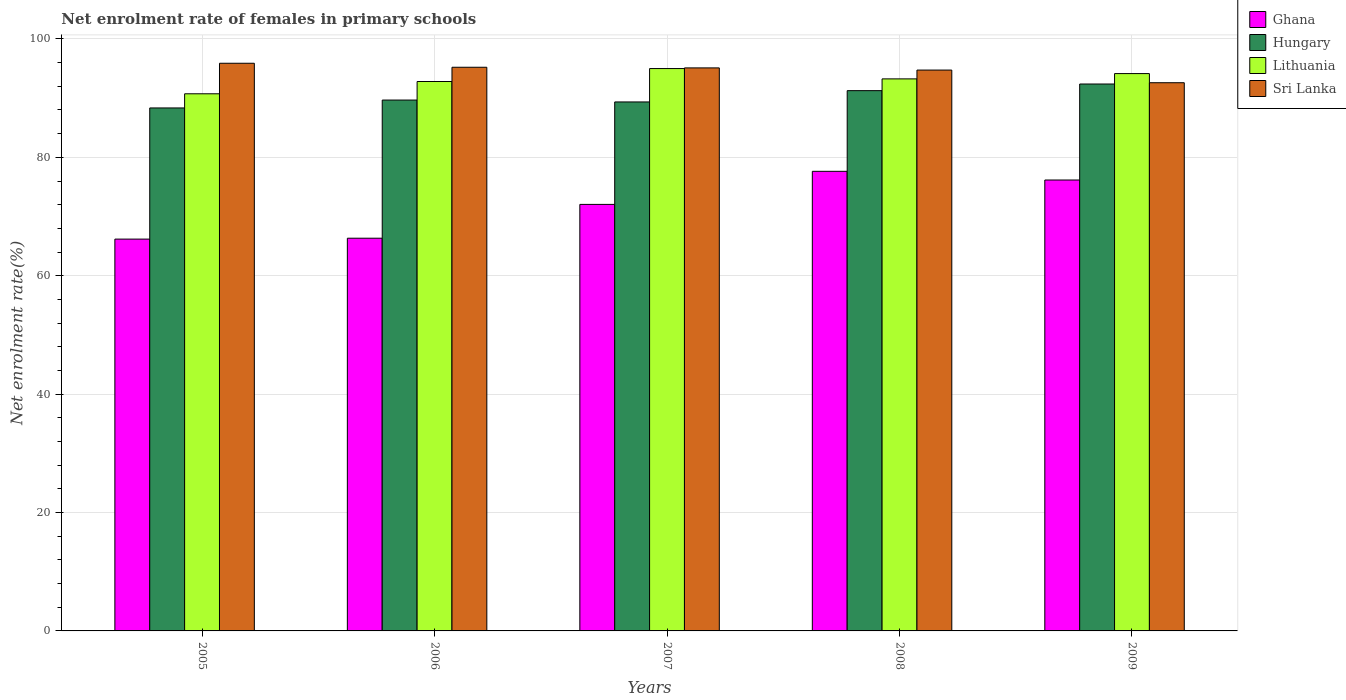Are the number of bars on each tick of the X-axis equal?
Offer a very short reply. Yes. How many bars are there on the 1st tick from the left?
Keep it short and to the point. 4. How many bars are there on the 4th tick from the right?
Keep it short and to the point. 4. What is the label of the 2nd group of bars from the left?
Your response must be concise. 2006. In how many cases, is the number of bars for a given year not equal to the number of legend labels?
Your answer should be compact. 0. What is the net enrolment rate of females in primary schools in Sri Lanka in 2008?
Offer a very short reply. 94.74. Across all years, what is the maximum net enrolment rate of females in primary schools in Lithuania?
Offer a very short reply. 95. Across all years, what is the minimum net enrolment rate of females in primary schools in Hungary?
Give a very brief answer. 88.35. In which year was the net enrolment rate of females in primary schools in Sri Lanka maximum?
Your answer should be very brief. 2005. In which year was the net enrolment rate of females in primary schools in Sri Lanka minimum?
Give a very brief answer. 2009. What is the total net enrolment rate of females in primary schools in Lithuania in the graph?
Ensure brevity in your answer.  465.96. What is the difference between the net enrolment rate of females in primary schools in Hungary in 2006 and that in 2007?
Ensure brevity in your answer.  0.32. What is the difference between the net enrolment rate of females in primary schools in Hungary in 2007 and the net enrolment rate of females in primary schools in Lithuania in 2005?
Your response must be concise. -1.38. What is the average net enrolment rate of females in primary schools in Lithuania per year?
Your response must be concise. 93.19. In the year 2009, what is the difference between the net enrolment rate of females in primary schools in Ghana and net enrolment rate of females in primary schools in Hungary?
Ensure brevity in your answer.  -16.22. In how many years, is the net enrolment rate of females in primary schools in Sri Lanka greater than 12 %?
Offer a very short reply. 5. What is the ratio of the net enrolment rate of females in primary schools in Ghana in 2006 to that in 2007?
Give a very brief answer. 0.92. Is the net enrolment rate of females in primary schools in Sri Lanka in 2008 less than that in 2009?
Provide a short and direct response. No. Is the difference between the net enrolment rate of females in primary schools in Ghana in 2005 and 2009 greater than the difference between the net enrolment rate of females in primary schools in Hungary in 2005 and 2009?
Your response must be concise. No. What is the difference between the highest and the second highest net enrolment rate of females in primary schools in Lithuania?
Provide a succinct answer. 0.85. What is the difference between the highest and the lowest net enrolment rate of females in primary schools in Ghana?
Provide a succinct answer. 11.45. In how many years, is the net enrolment rate of females in primary schools in Lithuania greater than the average net enrolment rate of females in primary schools in Lithuania taken over all years?
Your response must be concise. 3. Is the sum of the net enrolment rate of females in primary schools in Sri Lanka in 2005 and 2009 greater than the maximum net enrolment rate of females in primary schools in Ghana across all years?
Your answer should be compact. Yes. What does the 4th bar from the left in 2005 represents?
Your answer should be compact. Sri Lanka. What does the 4th bar from the right in 2008 represents?
Keep it short and to the point. Ghana. Are all the bars in the graph horizontal?
Give a very brief answer. No. How many legend labels are there?
Offer a very short reply. 4. What is the title of the graph?
Offer a very short reply. Net enrolment rate of females in primary schools. What is the label or title of the X-axis?
Offer a very short reply. Years. What is the label or title of the Y-axis?
Your answer should be compact. Net enrolment rate(%). What is the Net enrolment rate(%) of Ghana in 2005?
Offer a terse response. 66.19. What is the Net enrolment rate(%) of Hungary in 2005?
Provide a succinct answer. 88.35. What is the Net enrolment rate(%) in Lithuania in 2005?
Provide a short and direct response. 90.74. What is the Net enrolment rate(%) of Sri Lanka in 2005?
Provide a short and direct response. 95.89. What is the Net enrolment rate(%) in Ghana in 2006?
Make the answer very short. 66.34. What is the Net enrolment rate(%) of Hungary in 2006?
Keep it short and to the point. 89.68. What is the Net enrolment rate(%) in Lithuania in 2006?
Give a very brief answer. 92.81. What is the Net enrolment rate(%) in Sri Lanka in 2006?
Your answer should be very brief. 95.22. What is the Net enrolment rate(%) of Ghana in 2007?
Provide a succinct answer. 72.05. What is the Net enrolment rate(%) in Hungary in 2007?
Make the answer very short. 89.36. What is the Net enrolment rate(%) in Lithuania in 2007?
Provide a short and direct response. 95. What is the Net enrolment rate(%) in Sri Lanka in 2007?
Ensure brevity in your answer.  95.11. What is the Net enrolment rate(%) of Ghana in 2008?
Provide a succinct answer. 77.64. What is the Net enrolment rate(%) in Hungary in 2008?
Your response must be concise. 91.27. What is the Net enrolment rate(%) of Lithuania in 2008?
Your answer should be compact. 93.25. What is the Net enrolment rate(%) in Sri Lanka in 2008?
Provide a succinct answer. 94.74. What is the Net enrolment rate(%) of Ghana in 2009?
Make the answer very short. 76.17. What is the Net enrolment rate(%) of Hungary in 2009?
Give a very brief answer. 92.39. What is the Net enrolment rate(%) of Lithuania in 2009?
Offer a very short reply. 94.15. What is the Net enrolment rate(%) of Sri Lanka in 2009?
Ensure brevity in your answer.  92.61. Across all years, what is the maximum Net enrolment rate(%) of Ghana?
Offer a terse response. 77.64. Across all years, what is the maximum Net enrolment rate(%) in Hungary?
Provide a short and direct response. 92.39. Across all years, what is the maximum Net enrolment rate(%) of Lithuania?
Make the answer very short. 95. Across all years, what is the maximum Net enrolment rate(%) in Sri Lanka?
Your answer should be compact. 95.89. Across all years, what is the minimum Net enrolment rate(%) of Ghana?
Ensure brevity in your answer.  66.19. Across all years, what is the minimum Net enrolment rate(%) in Hungary?
Give a very brief answer. 88.35. Across all years, what is the minimum Net enrolment rate(%) in Lithuania?
Your answer should be compact. 90.74. Across all years, what is the minimum Net enrolment rate(%) of Sri Lanka?
Make the answer very short. 92.61. What is the total Net enrolment rate(%) in Ghana in the graph?
Your answer should be compact. 358.4. What is the total Net enrolment rate(%) in Hungary in the graph?
Give a very brief answer. 451.04. What is the total Net enrolment rate(%) of Lithuania in the graph?
Your answer should be very brief. 465.96. What is the total Net enrolment rate(%) in Sri Lanka in the graph?
Provide a short and direct response. 473.58. What is the difference between the Net enrolment rate(%) in Ghana in 2005 and that in 2006?
Offer a terse response. -0.15. What is the difference between the Net enrolment rate(%) of Hungary in 2005 and that in 2006?
Offer a very short reply. -1.33. What is the difference between the Net enrolment rate(%) in Lithuania in 2005 and that in 2006?
Offer a very short reply. -2.07. What is the difference between the Net enrolment rate(%) of Sri Lanka in 2005 and that in 2006?
Your answer should be compact. 0.68. What is the difference between the Net enrolment rate(%) of Ghana in 2005 and that in 2007?
Your answer should be compact. -5.86. What is the difference between the Net enrolment rate(%) in Hungary in 2005 and that in 2007?
Offer a very short reply. -1.01. What is the difference between the Net enrolment rate(%) in Lithuania in 2005 and that in 2007?
Your answer should be compact. -4.26. What is the difference between the Net enrolment rate(%) in Sri Lanka in 2005 and that in 2007?
Provide a succinct answer. 0.78. What is the difference between the Net enrolment rate(%) in Ghana in 2005 and that in 2008?
Provide a short and direct response. -11.45. What is the difference between the Net enrolment rate(%) in Hungary in 2005 and that in 2008?
Provide a short and direct response. -2.92. What is the difference between the Net enrolment rate(%) of Lithuania in 2005 and that in 2008?
Give a very brief answer. -2.52. What is the difference between the Net enrolment rate(%) of Sri Lanka in 2005 and that in 2008?
Your answer should be very brief. 1.15. What is the difference between the Net enrolment rate(%) of Ghana in 2005 and that in 2009?
Provide a short and direct response. -9.98. What is the difference between the Net enrolment rate(%) in Hungary in 2005 and that in 2009?
Provide a short and direct response. -4.04. What is the difference between the Net enrolment rate(%) of Lithuania in 2005 and that in 2009?
Your answer should be very brief. -3.41. What is the difference between the Net enrolment rate(%) in Sri Lanka in 2005 and that in 2009?
Give a very brief answer. 3.29. What is the difference between the Net enrolment rate(%) in Ghana in 2006 and that in 2007?
Make the answer very short. -5.71. What is the difference between the Net enrolment rate(%) in Hungary in 2006 and that in 2007?
Keep it short and to the point. 0.32. What is the difference between the Net enrolment rate(%) of Lithuania in 2006 and that in 2007?
Your answer should be very brief. -2.19. What is the difference between the Net enrolment rate(%) of Sri Lanka in 2006 and that in 2007?
Provide a short and direct response. 0.11. What is the difference between the Net enrolment rate(%) of Ghana in 2006 and that in 2008?
Your response must be concise. -11.3. What is the difference between the Net enrolment rate(%) in Hungary in 2006 and that in 2008?
Ensure brevity in your answer.  -1.59. What is the difference between the Net enrolment rate(%) of Lithuania in 2006 and that in 2008?
Make the answer very short. -0.44. What is the difference between the Net enrolment rate(%) of Sri Lanka in 2006 and that in 2008?
Make the answer very short. 0.47. What is the difference between the Net enrolment rate(%) in Ghana in 2006 and that in 2009?
Give a very brief answer. -9.83. What is the difference between the Net enrolment rate(%) in Hungary in 2006 and that in 2009?
Offer a very short reply. -2.71. What is the difference between the Net enrolment rate(%) in Lithuania in 2006 and that in 2009?
Provide a short and direct response. -1.34. What is the difference between the Net enrolment rate(%) in Sri Lanka in 2006 and that in 2009?
Your response must be concise. 2.61. What is the difference between the Net enrolment rate(%) of Ghana in 2007 and that in 2008?
Your answer should be compact. -5.59. What is the difference between the Net enrolment rate(%) of Hungary in 2007 and that in 2008?
Your answer should be very brief. -1.91. What is the difference between the Net enrolment rate(%) of Lithuania in 2007 and that in 2008?
Ensure brevity in your answer.  1.74. What is the difference between the Net enrolment rate(%) in Sri Lanka in 2007 and that in 2008?
Offer a very short reply. 0.37. What is the difference between the Net enrolment rate(%) of Ghana in 2007 and that in 2009?
Provide a short and direct response. -4.12. What is the difference between the Net enrolment rate(%) of Hungary in 2007 and that in 2009?
Offer a very short reply. -3.03. What is the difference between the Net enrolment rate(%) in Lithuania in 2007 and that in 2009?
Your answer should be compact. 0.85. What is the difference between the Net enrolment rate(%) of Sri Lanka in 2007 and that in 2009?
Your answer should be compact. 2.5. What is the difference between the Net enrolment rate(%) in Ghana in 2008 and that in 2009?
Your answer should be very brief. 1.47. What is the difference between the Net enrolment rate(%) in Hungary in 2008 and that in 2009?
Provide a short and direct response. -1.12. What is the difference between the Net enrolment rate(%) of Lithuania in 2008 and that in 2009?
Offer a very short reply. -0.9. What is the difference between the Net enrolment rate(%) in Sri Lanka in 2008 and that in 2009?
Give a very brief answer. 2.14. What is the difference between the Net enrolment rate(%) of Ghana in 2005 and the Net enrolment rate(%) of Hungary in 2006?
Keep it short and to the point. -23.49. What is the difference between the Net enrolment rate(%) in Ghana in 2005 and the Net enrolment rate(%) in Lithuania in 2006?
Your response must be concise. -26.62. What is the difference between the Net enrolment rate(%) in Ghana in 2005 and the Net enrolment rate(%) in Sri Lanka in 2006?
Ensure brevity in your answer.  -29.03. What is the difference between the Net enrolment rate(%) of Hungary in 2005 and the Net enrolment rate(%) of Lithuania in 2006?
Make the answer very short. -4.47. What is the difference between the Net enrolment rate(%) in Hungary in 2005 and the Net enrolment rate(%) in Sri Lanka in 2006?
Make the answer very short. -6.87. What is the difference between the Net enrolment rate(%) of Lithuania in 2005 and the Net enrolment rate(%) of Sri Lanka in 2006?
Your answer should be very brief. -4.48. What is the difference between the Net enrolment rate(%) in Ghana in 2005 and the Net enrolment rate(%) in Hungary in 2007?
Make the answer very short. -23.17. What is the difference between the Net enrolment rate(%) of Ghana in 2005 and the Net enrolment rate(%) of Lithuania in 2007?
Your answer should be compact. -28.81. What is the difference between the Net enrolment rate(%) of Ghana in 2005 and the Net enrolment rate(%) of Sri Lanka in 2007?
Provide a short and direct response. -28.92. What is the difference between the Net enrolment rate(%) of Hungary in 2005 and the Net enrolment rate(%) of Lithuania in 2007?
Give a very brief answer. -6.65. What is the difference between the Net enrolment rate(%) in Hungary in 2005 and the Net enrolment rate(%) in Sri Lanka in 2007?
Your answer should be very brief. -6.76. What is the difference between the Net enrolment rate(%) in Lithuania in 2005 and the Net enrolment rate(%) in Sri Lanka in 2007?
Offer a very short reply. -4.37. What is the difference between the Net enrolment rate(%) of Ghana in 2005 and the Net enrolment rate(%) of Hungary in 2008?
Offer a very short reply. -25.08. What is the difference between the Net enrolment rate(%) of Ghana in 2005 and the Net enrolment rate(%) of Lithuania in 2008?
Provide a succinct answer. -27.06. What is the difference between the Net enrolment rate(%) of Ghana in 2005 and the Net enrolment rate(%) of Sri Lanka in 2008?
Keep it short and to the point. -28.55. What is the difference between the Net enrolment rate(%) in Hungary in 2005 and the Net enrolment rate(%) in Lithuania in 2008?
Your response must be concise. -4.91. What is the difference between the Net enrolment rate(%) of Hungary in 2005 and the Net enrolment rate(%) of Sri Lanka in 2008?
Your answer should be compact. -6.4. What is the difference between the Net enrolment rate(%) in Lithuania in 2005 and the Net enrolment rate(%) in Sri Lanka in 2008?
Keep it short and to the point. -4.01. What is the difference between the Net enrolment rate(%) in Ghana in 2005 and the Net enrolment rate(%) in Hungary in 2009?
Give a very brief answer. -26.2. What is the difference between the Net enrolment rate(%) of Ghana in 2005 and the Net enrolment rate(%) of Lithuania in 2009?
Offer a terse response. -27.96. What is the difference between the Net enrolment rate(%) of Ghana in 2005 and the Net enrolment rate(%) of Sri Lanka in 2009?
Your answer should be compact. -26.42. What is the difference between the Net enrolment rate(%) of Hungary in 2005 and the Net enrolment rate(%) of Lithuania in 2009?
Keep it short and to the point. -5.8. What is the difference between the Net enrolment rate(%) in Hungary in 2005 and the Net enrolment rate(%) in Sri Lanka in 2009?
Provide a succinct answer. -4.26. What is the difference between the Net enrolment rate(%) of Lithuania in 2005 and the Net enrolment rate(%) of Sri Lanka in 2009?
Provide a succinct answer. -1.87. What is the difference between the Net enrolment rate(%) in Ghana in 2006 and the Net enrolment rate(%) in Hungary in 2007?
Your answer should be very brief. -23.02. What is the difference between the Net enrolment rate(%) in Ghana in 2006 and the Net enrolment rate(%) in Lithuania in 2007?
Make the answer very short. -28.66. What is the difference between the Net enrolment rate(%) of Ghana in 2006 and the Net enrolment rate(%) of Sri Lanka in 2007?
Your answer should be very brief. -28.77. What is the difference between the Net enrolment rate(%) in Hungary in 2006 and the Net enrolment rate(%) in Lithuania in 2007?
Make the answer very short. -5.32. What is the difference between the Net enrolment rate(%) of Hungary in 2006 and the Net enrolment rate(%) of Sri Lanka in 2007?
Ensure brevity in your answer.  -5.43. What is the difference between the Net enrolment rate(%) in Lithuania in 2006 and the Net enrolment rate(%) in Sri Lanka in 2007?
Give a very brief answer. -2.3. What is the difference between the Net enrolment rate(%) of Ghana in 2006 and the Net enrolment rate(%) of Hungary in 2008?
Your response must be concise. -24.93. What is the difference between the Net enrolment rate(%) in Ghana in 2006 and the Net enrolment rate(%) in Lithuania in 2008?
Offer a very short reply. -26.91. What is the difference between the Net enrolment rate(%) of Ghana in 2006 and the Net enrolment rate(%) of Sri Lanka in 2008?
Provide a short and direct response. -28.4. What is the difference between the Net enrolment rate(%) in Hungary in 2006 and the Net enrolment rate(%) in Lithuania in 2008?
Keep it short and to the point. -3.58. What is the difference between the Net enrolment rate(%) of Hungary in 2006 and the Net enrolment rate(%) of Sri Lanka in 2008?
Your response must be concise. -5.07. What is the difference between the Net enrolment rate(%) in Lithuania in 2006 and the Net enrolment rate(%) in Sri Lanka in 2008?
Keep it short and to the point. -1.93. What is the difference between the Net enrolment rate(%) in Ghana in 2006 and the Net enrolment rate(%) in Hungary in 2009?
Your answer should be compact. -26.05. What is the difference between the Net enrolment rate(%) in Ghana in 2006 and the Net enrolment rate(%) in Lithuania in 2009?
Give a very brief answer. -27.81. What is the difference between the Net enrolment rate(%) in Ghana in 2006 and the Net enrolment rate(%) in Sri Lanka in 2009?
Your answer should be very brief. -26.27. What is the difference between the Net enrolment rate(%) in Hungary in 2006 and the Net enrolment rate(%) in Lithuania in 2009?
Keep it short and to the point. -4.47. What is the difference between the Net enrolment rate(%) in Hungary in 2006 and the Net enrolment rate(%) in Sri Lanka in 2009?
Provide a short and direct response. -2.93. What is the difference between the Net enrolment rate(%) in Lithuania in 2006 and the Net enrolment rate(%) in Sri Lanka in 2009?
Provide a succinct answer. 0.21. What is the difference between the Net enrolment rate(%) in Ghana in 2007 and the Net enrolment rate(%) in Hungary in 2008?
Provide a succinct answer. -19.22. What is the difference between the Net enrolment rate(%) in Ghana in 2007 and the Net enrolment rate(%) in Lithuania in 2008?
Keep it short and to the point. -21.2. What is the difference between the Net enrolment rate(%) of Ghana in 2007 and the Net enrolment rate(%) of Sri Lanka in 2008?
Keep it short and to the point. -22.69. What is the difference between the Net enrolment rate(%) of Hungary in 2007 and the Net enrolment rate(%) of Lithuania in 2008?
Offer a terse response. -3.9. What is the difference between the Net enrolment rate(%) of Hungary in 2007 and the Net enrolment rate(%) of Sri Lanka in 2008?
Keep it short and to the point. -5.39. What is the difference between the Net enrolment rate(%) of Lithuania in 2007 and the Net enrolment rate(%) of Sri Lanka in 2008?
Provide a short and direct response. 0.25. What is the difference between the Net enrolment rate(%) in Ghana in 2007 and the Net enrolment rate(%) in Hungary in 2009?
Offer a very short reply. -20.34. What is the difference between the Net enrolment rate(%) of Ghana in 2007 and the Net enrolment rate(%) of Lithuania in 2009?
Provide a succinct answer. -22.1. What is the difference between the Net enrolment rate(%) in Ghana in 2007 and the Net enrolment rate(%) in Sri Lanka in 2009?
Keep it short and to the point. -20.55. What is the difference between the Net enrolment rate(%) of Hungary in 2007 and the Net enrolment rate(%) of Lithuania in 2009?
Make the answer very short. -4.79. What is the difference between the Net enrolment rate(%) in Hungary in 2007 and the Net enrolment rate(%) in Sri Lanka in 2009?
Your answer should be very brief. -3.25. What is the difference between the Net enrolment rate(%) in Lithuania in 2007 and the Net enrolment rate(%) in Sri Lanka in 2009?
Ensure brevity in your answer.  2.39. What is the difference between the Net enrolment rate(%) of Ghana in 2008 and the Net enrolment rate(%) of Hungary in 2009?
Provide a short and direct response. -14.75. What is the difference between the Net enrolment rate(%) in Ghana in 2008 and the Net enrolment rate(%) in Lithuania in 2009?
Make the answer very short. -16.51. What is the difference between the Net enrolment rate(%) of Ghana in 2008 and the Net enrolment rate(%) of Sri Lanka in 2009?
Your response must be concise. -14.97. What is the difference between the Net enrolment rate(%) in Hungary in 2008 and the Net enrolment rate(%) in Lithuania in 2009?
Give a very brief answer. -2.88. What is the difference between the Net enrolment rate(%) of Hungary in 2008 and the Net enrolment rate(%) of Sri Lanka in 2009?
Keep it short and to the point. -1.34. What is the difference between the Net enrolment rate(%) of Lithuania in 2008 and the Net enrolment rate(%) of Sri Lanka in 2009?
Your response must be concise. 0.65. What is the average Net enrolment rate(%) in Ghana per year?
Ensure brevity in your answer.  71.68. What is the average Net enrolment rate(%) of Hungary per year?
Offer a very short reply. 90.21. What is the average Net enrolment rate(%) in Lithuania per year?
Your response must be concise. 93.19. What is the average Net enrolment rate(%) in Sri Lanka per year?
Your response must be concise. 94.72. In the year 2005, what is the difference between the Net enrolment rate(%) in Ghana and Net enrolment rate(%) in Hungary?
Ensure brevity in your answer.  -22.16. In the year 2005, what is the difference between the Net enrolment rate(%) of Ghana and Net enrolment rate(%) of Lithuania?
Give a very brief answer. -24.55. In the year 2005, what is the difference between the Net enrolment rate(%) of Ghana and Net enrolment rate(%) of Sri Lanka?
Give a very brief answer. -29.7. In the year 2005, what is the difference between the Net enrolment rate(%) of Hungary and Net enrolment rate(%) of Lithuania?
Offer a terse response. -2.39. In the year 2005, what is the difference between the Net enrolment rate(%) in Hungary and Net enrolment rate(%) in Sri Lanka?
Your answer should be very brief. -7.55. In the year 2005, what is the difference between the Net enrolment rate(%) in Lithuania and Net enrolment rate(%) in Sri Lanka?
Your answer should be compact. -5.16. In the year 2006, what is the difference between the Net enrolment rate(%) in Ghana and Net enrolment rate(%) in Hungary?
Keep it short and to the point. -23.34. In the year 2006, what is the difference between the Net enrolment rate(%) in Ghana and Net enrolment rate(%) in Lithuania?
Make the answer very short. -26.47. In the year 2006, what is the difference between the Net enrolment rate(%) of Ghana and Net enrolment rate(%) of Sri Lanka?
Keep it short and to the point. -28.88. In the year 2006, what is the difference between the Net enrolment rate(%) of Hungary and Net enrolment rate(%) of Lithuania?
Make the answer very short. -3.13. In the year 2006, what is the difference between the Net enrolment rate(%) of Hungary and Net enrolment rate(%) of Sri Lanka?
Make the answer very short. -5.54. In the year 2006, what is the difference between the Net enrolment rate(%) in Lithuania and Net enrolment rate(%) in Sri Lanka?
Your response must be concise. -2.41. In the year 2007, what is the difference between the Net enrolment rate(%) of Ghana and Net enrolment rate(%) of Hungary?
Make the answer very short. -17.31. In the year 2007, what is the difference between the Net enrolment rate(%) of Ghana and Net enrolment rate(%) of Lithuania?
Provide a short and direct response. -22.95. In the year 2007, what is the difference between the Net enrolment rate(%) of Ghana and Net enrolment rate(%) of Sri Lanka?
Provide a succinct answer. -23.06. In the year 2007, what is the difference between the Net enrolment rate(%) in Hungary and Net enrolment rate(%) in Lithuania?
Provide a succinct answer. -5.64. In the year 2007, what is the difference between the Net enrolment rate(%) of Hungary and Net enrolment rate(%) of Sri Lanka?
Your answer should be compact. -5.75. In the year 2007, what is the difference between the Net enrolment rate(%) of Lithuania and Net enrolment rate(%) of Sri Lanka?
Your answer should be very brief. -0.11. In the year 2008, what is the difference between the Net enrolment rate(%) of Ghana and Net enrolment rate(%) of Hungary?
Provide a short and direct response. -13.63. In the year 2008, what is the difference between the Net enrolment rate(%) in Ghana and Net enrolment rate(%) in Lithuania?
Provide a short and direct response. -15.62. In the year 2008, what is the difference between the Net enrolment rate(%) in Ghana and Net enrolment rate(%) in Sri Lanka?
Your answer should be compact. -17.1. In the year 2008, what is the difference between the Net enrolment rate(%) of Hungary and Net enrolment rate(%) of Lithuania?
Give a very brief answer. -1.99. In the year 2008, what is the difference between the Net enrolment rate(%) of Hungary and Net enrolment rate(%) of Sri Lanka?
Offer a terse response. -3.48. In the year 2008, what is the difference between the Net enrolment rate(%) in Lithuania and Net enrolment rate(%) in Sri Lanka?
Provide a succinct answer. -1.49. In the year 2009, what is the difference between the Net enrolment rate(%) in Ghana and Net enrolment rate(%) in Hungary?
Ensure brevity in your answer.  -16.22. In the year 2009, what is the difference between the Net enrolment rate(%) of Ghana and Net enrolment rate(%) of Lithuania?
Keep it short and to the point. -17.98. In the year 2009, what is the difference between the Net enrolment rate(%) in Ghana and Net enrolment rate(%) in Sri Lanka?
Make the answer very short. -16.43. In the year 2009, what is the difference between the Net enrolment rate(%) of Hungary and Net enrolment rate(%) of Lithuania?
Provide a short and direct response. -1.76. In the year 2009, what is the difference between the Net enrolment rate(%) in Hungary and Net enrolment rate(%) in Sri Lanka?
Your response must be concise. -0.22. In the year 2009, what is the difference between the Net enrolment rate(%) in Lithuania and Net enrolment rate(%) in Sri Lanka?
Offer a terse response. 1.54. What is the ratio of the Net enrolment rate(%) of Hungary in 2005 to that in 2006?
Ensure brevity in your answer.  0.99. What is the ratio of the Net enrolment rate(%) of Lithuania in 2005 to that in 2006?
Ensure brevity in your answer.  0.98. What is the ratio of the Net enrolment rate(%) in Sri Lanka in 2005 to that in 2006?
Give a very brief answer. 1.01. What is the ratio of the Net enrolment rate(%) in Ghana in 2005 to that in 2007?
Provide a succinct answer. 0.92. What is the ratio of the Net enrolment rate(%) in Hungary in 2005 to that in 2007?
Your answer should be compact. 0.99. What is the ratio of the Net enrolment rate(%) of Lithuania in 2005 to that in 2007?
Provide a short and direct response. 0.96. What is the ratio of the Net enrolment rate(%) of Sri Lanka in 2005 to that in 2007?
Offer a terse response. 1.01. What is the ratio of the Net enrolment rate(%) of Ghana in 2005 to that in 2008?
Your response must be concise. 0.85. What is the ratio of the Net enrolment rate(%) in Hungary in 2005 to that in 2008?
Offer a terse response. 0.97. What is the ratio of the Net enrolment rate(%) in Sri Lanka in 2005 to that in 2008?
Your answer should be very brief. 1.01. What is the ratio of the Net enrolment rate(%) in Ghana in 2005 to that in 2009?
Ensure brevity in your answer.  0.87. What is the ratio of the Net enrolment rate(%) in Hungary in 2005 to that in 2009?
Make the answer very short. 0.96. What is the ratio of the Net enrolment rate(%) in Lithuania in 2005 to that in 2009?
Keep it short and to the point. 0.96. What is the ratio of the Net enrolment rate(%) in Sri Lanka in 2005 to that in 2009?
Your response must be concise. 1.04. What is the ratio of the Net enrolment rate(%) of Ghana in 2006 to that in 2007?
Your answer should be very brief. 0.92. What is the ratio of the Net enrolment rate(%) of Hungary in 2006 to that in 2007?
Provide a succinct answer. 1. What is the ratio of the Net enrolment rate(%) in Lithuania in 2006 to that in 2007?
Give a very brief answer. 0.98. What is the ratio of the Net enrolment rate(%) in Ghana in 2006 to that in 2008?
Provide a succinct answer. 0.85. What is the ratio of the Net enrolment rate(%) in Hungary in 2006 to that in 2008?
Give a very brief answer. 0.98. What is the ratio of the Net enrolment rate(%) in Sri Lanka in 2006 to that in 2008?
Provide a succinct answer. 1. What is the ratio of the Net enrolment rate(%) in Ghana in 2006 to that in 2009?
Offer a very short reply. 0.87. What is the ratio of the Net enrolment rate(%) of Hungary in 2006 to that in 2009?
Give a very brief answer. 0.97. What is the ratio of the Net enrolment rate(%) in Lithuania in 2006 to that in 2009?
Give a very brief answer. 0.99. What is the ratio of the Net enrolment rate(%) in Sri Lanka in 2006 to that in 2009?
Provide a short and direct response. 1.03. What is the ratio of the Net enrolment rate(%) of Ghana in 2007 to that in 2008?
Offer a very short reply. 0.93. What is the ratio of the Net enrolment rate(%) in Hungary in 2007 to that in 2008?
Make the answer very short. 0.98. What is the ratio of the Net enrolment rate(%) of Lithuania in 2007 to that in 2008?
Offer a very short reply. 1.02. What is the ratio of the Net enrolment rate(%) of Ghana in 2007 to that in 2009?
Offer a very short reply. 0.95. What is the ratio of the Net enrolment rate(%) in Hungary in 2007 to that in 2009?
Your answer should be compact. 0.97. What is the ratio of the Net enrolment rate(%) of Sri Lanka in 2007 to that in 2009?
Provide a succinct answer. 1.03. What is the ratio of the Net enrolment rate(%) of Ghana in 2008 to that in 2009?
Provide a short and direct response. 1.02. What is the ratio of the Net enrolment rate(%) in Hungary in 2008 to that in 2009?
Your answer should be compact. 0.99. What is the ratio of the Net enrolment rate(%) of Lithuania in 2008 to that in 2009?
Keep it short and to the point. 0.99. What is the ratio of the Net enrolment rate(%) in Sri Lanka in 2008 to that in 2009?
Your answer should be compact. 1.02. What is the difference between the highest and the second highest Net enrolment rate(%) of Ghana?
Offer a very short reply. 1.47. What is the difference between the highest and the second highest Net enrolment rate(%) of Hungary?
Keep it short and to the point. 1.12. What is the difference between the highest and the second highest Net enrolment rate(%) in Lithuania?
Give a very brief answer. 0.85. What is the difference between the highest and the second highest Net enrolment rate(%) in Sri Lanka?
Ensure brevity in your answer.  0.68. What is the difference between the highest and the lowest Net enrolment rate(%) of Ghana?
Offer a very short reply. 11.45. What is the difference between the highest and the lowest Net enrolment rate(%) of Hungary?
Provide a short and direct response. 4.04. What is the difference between the highest and the lowest Net enrolment rate(%) of Lithuania?
Give a very brief answer. 4.26. What is the difference between the highest and the lowest Net enrolment rate(%) in Sri Lanka?
Offer a very short reply. 3.29. 